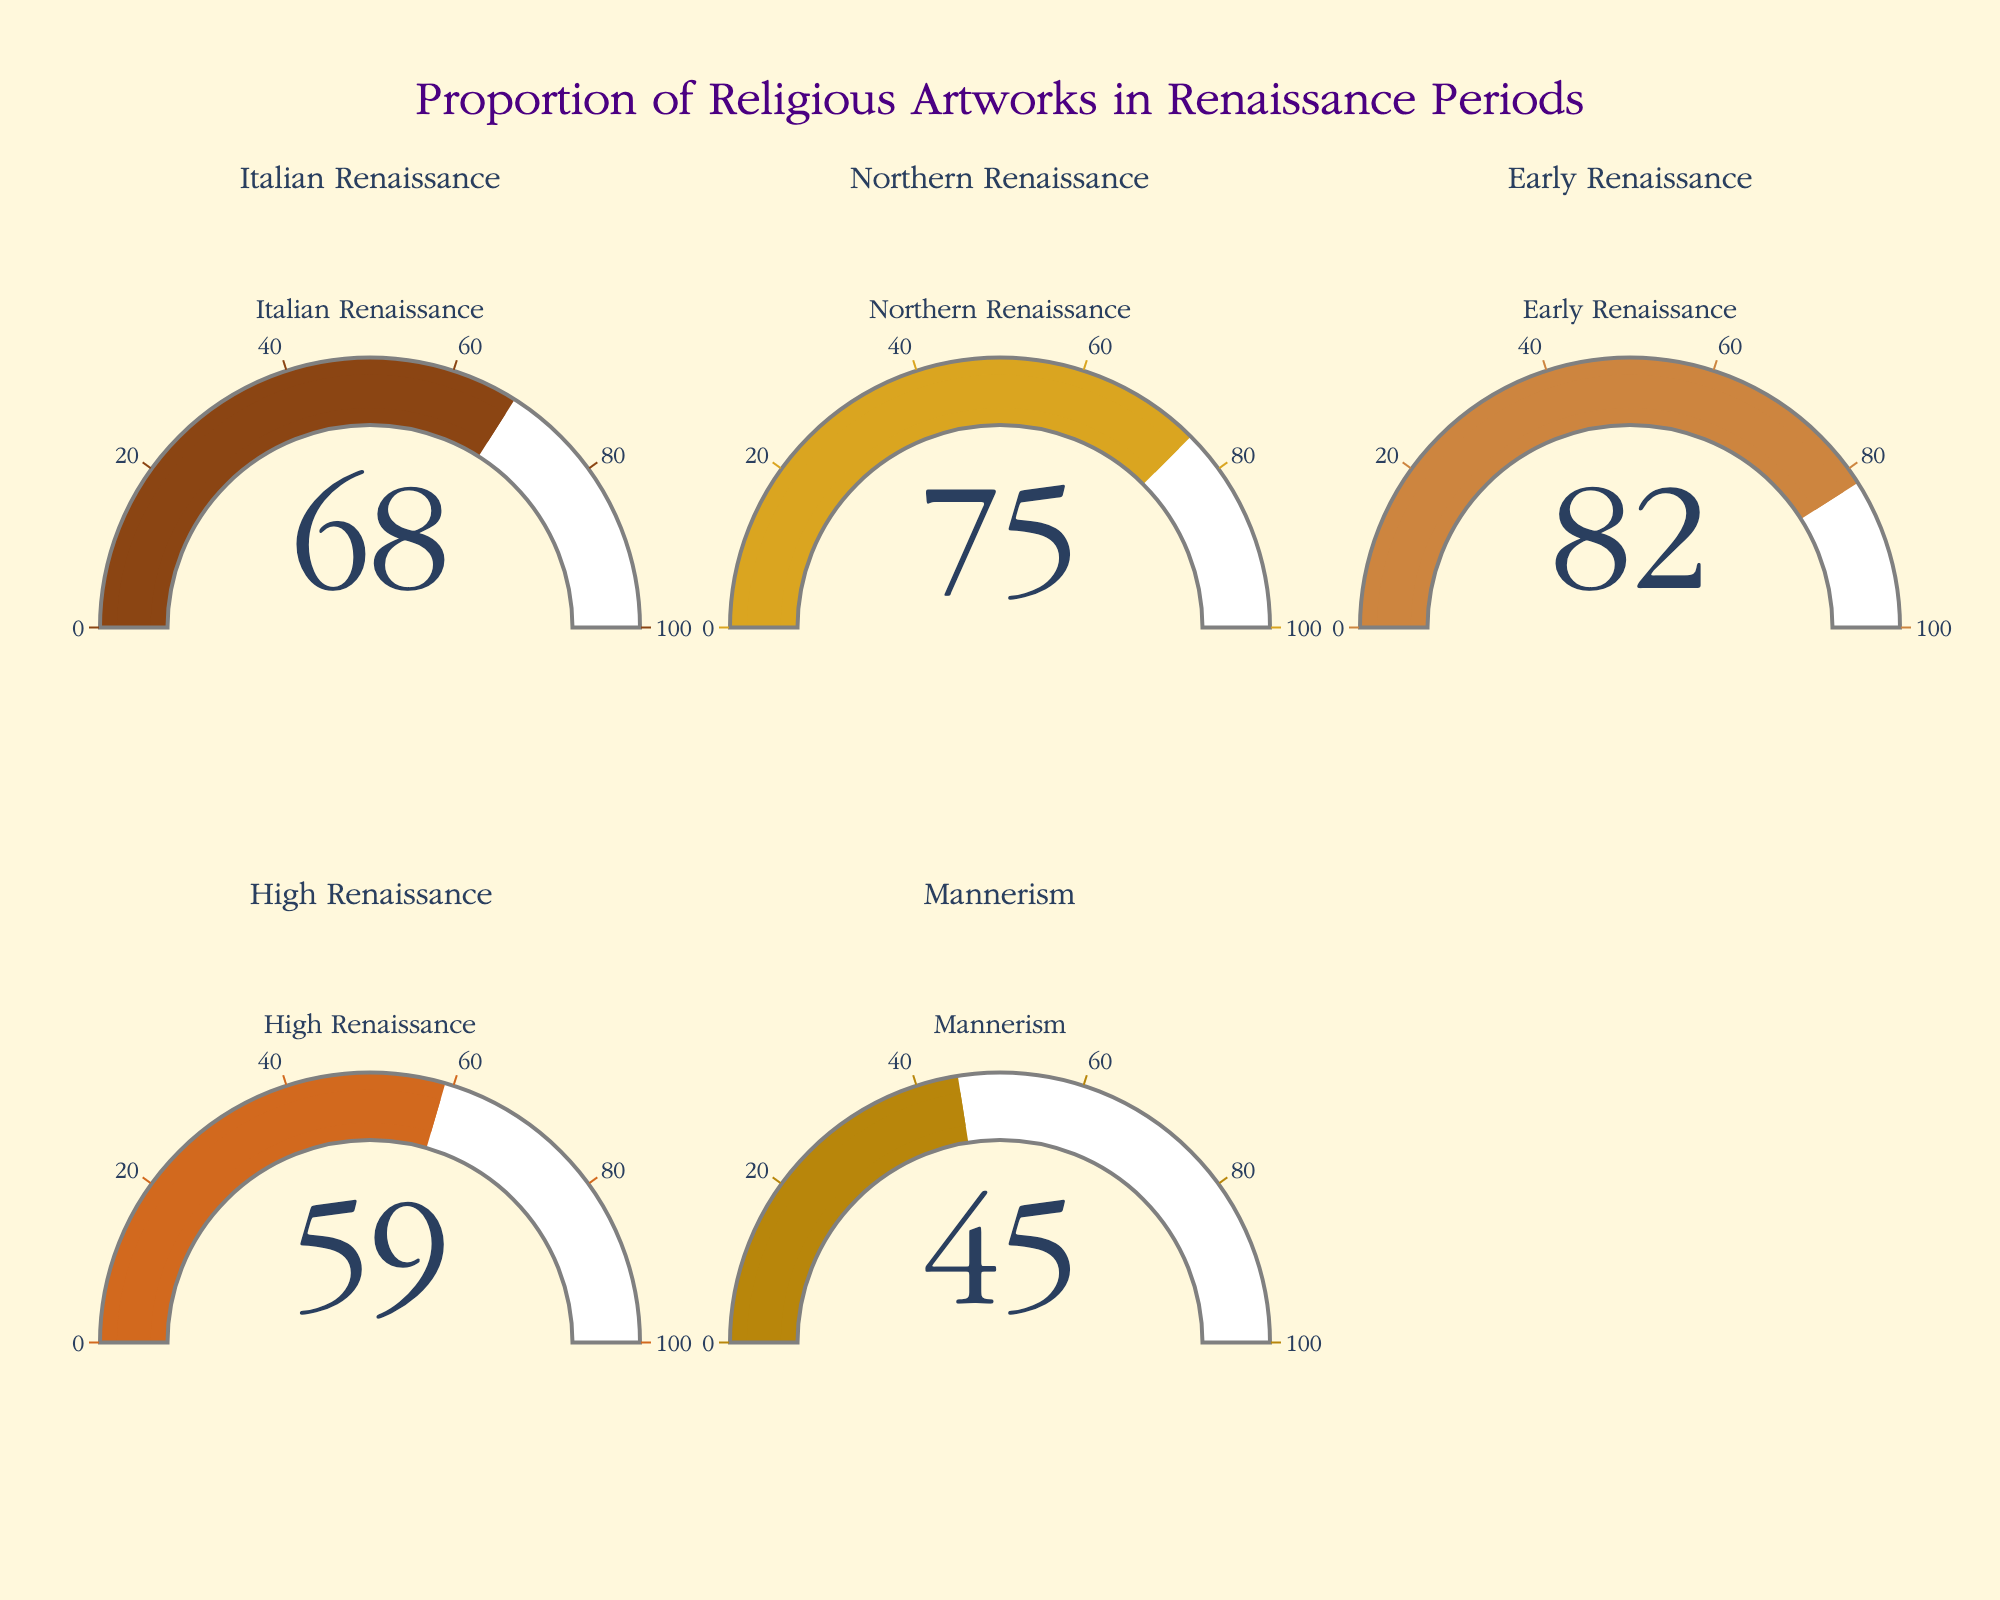what's the title of the figure? The title is located at the top center of the figure and is designed to give an overview of what the figure is about. In this case, the title is "Proportion of Religious Artworks in Renaissance Periods".
Answer: Proportion of Religious Artworks in Renaissance Periods how many gauge charts are present? By looking at the number of individual gauge indicators within the plot, we can count a total of 5 gauge charts.
Answer: 5 which category has the highest proportion of religious artworks? To determine this, examine the values displayed on each gauge chart and identify the highest one. The highest value is for the Early Renaissance at 82%.
Answer: Early Renaissance what is the proportion of religious artworks in the High Renaissance? Locate the High Renaissance gauge chart and read the value displayed. It shows 59%.
Answer: 59% which category has the lowest proportion of religious artworks? The lowest value among the gauge charts is for Mannerism, which shows 45%.
Answer: Mannerism how much higher is the proportion of religious artworks in the Early Renaissance compared to Mannerism? Subtract the value of Mannerism (45%) from the value of the Early Renaissance (82%). The difference is 82% - 45% = 37%.
Answer: 37% what is the average proportion of religious artworks across all categories? To find the average, sum all the proportions and then divide by the number of categories. The sum is (68 + 75 + 82 + 59 + 45) = 329. Dividing by 5 gives 329 / 5 = 65.8%.
Answer: 65.8% which period had more religious artworks, the Northern Renaissance or the Italian Renaissance? Compare the values: Northern Renaissance has 75%, and Italian Renaissance has 68%. Thus, the Northern Renaissance has more religious artworks.
Answer: Northern Renaissance what's the total proportion of religious artworks for the Northern and High Renaissance combined? Add the proportions for the Northern Renaissance (75%) and High Renaissance (59%). The total is 75% + 59% = 134%.
Answer: 134% 